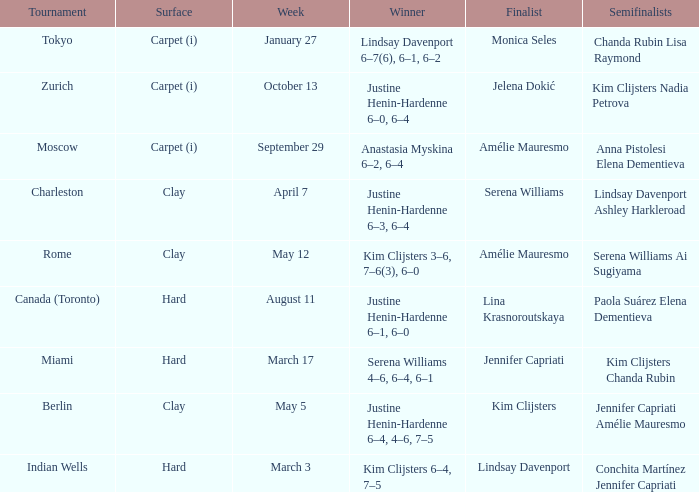Who was the winner against Lindsay Davenport? Kim Clijsters 6–4, 7–5. 